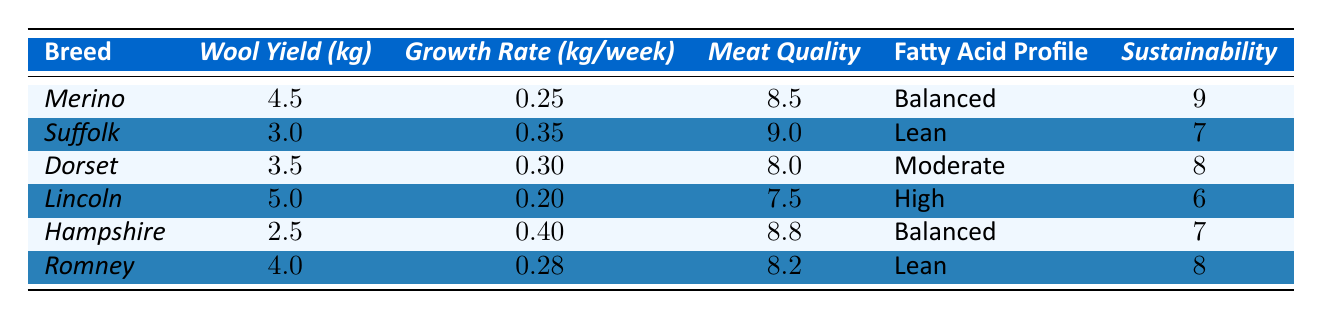What is the wool yield of the Merino breed? The table shows that the wool yield for the Merino breed is specifically listed as 4.5 kg.
Answer: 4.5 kg Which breed has the highest sustainability score? The sustainability scores are listed: Merino has 9, Suffolk has 7, Dorset has 8, Lincoln has 6, Hampshire has 7, and Romney has 8. The highest score is 9, belonging to Merino.
Answer: Merino What is the average growth rate of all breeds listed? To find the average growth rate, sum the growth rates (0.25 + 0.35 + 0.30 + 0.20 + 0.40 + 0.28 = 1.68) and divide by the number of breeds (6): 1.68 / 6 = 0.28.
Answer: 0.28 kg/week Is the meat quality score for Suffolk greater than that for Dorset? The meat quality score for Suffolk is 9.0, while for Dorset it is 8.0, which indicates that the score for Suffolk is greater than for Dorset.
Answer: Yes Which breed yields more wool, Dorset or Romney? The wool yield for Dorset is 3.5 kg, while for Romney it is 4.0 kg. Comparing these values shows that Romney yields more wool.
Answer: Romney What is the difference in sustainability score between Merino and Lincoln? The sustainability score for Merino is 9 and for Lincoln is 6. The difference is 9 - 6 = 3.
Answer: 3 Which breeds have a balanced fatty acid profile? Looking through the fatty acid profile column, Merino and Hampshire are both listed as having a balanced profile.
Answer: Merino, Hampshire If we average the meat quality scores of breeds with a sustainability score of 8 or above, what is the result? The breeds with a sustainability score of 8 or above are Merino (8.5), Dorset (8.0), and Romney (8.2). The average is (8.5 + 8.0 + 8.2) / 3 = 8.23.
Answer: 8.23 How many breeds have a growth rate greater than 0.30 kg/week? The breeds with growth rates greater than 0.30 kg/week are Suffolk (0.35), Hampshire (0.40), and Dorset (0.30). Suffolk and Hampshire fulfill this criterion, totaling 2 breeds.
Answer: 2 breeds What is the highest meat quality score, and which breed has it? Among the listed meat quality scores, Suffolk has the highest score at 9.0.
Answer: 9.0, Suffolk 